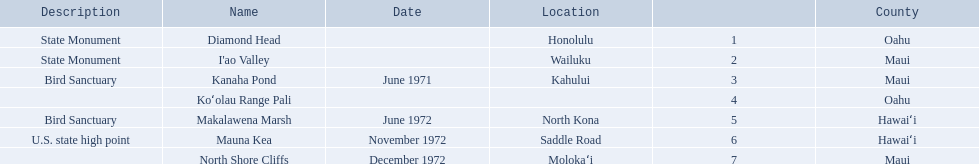Which national natural landmarks in hawaii are in oahu county? Diamond Head, Koʻolau Range Pali. Of these landmarks, which one is listed without a location? Koʻolau Range Pali. 